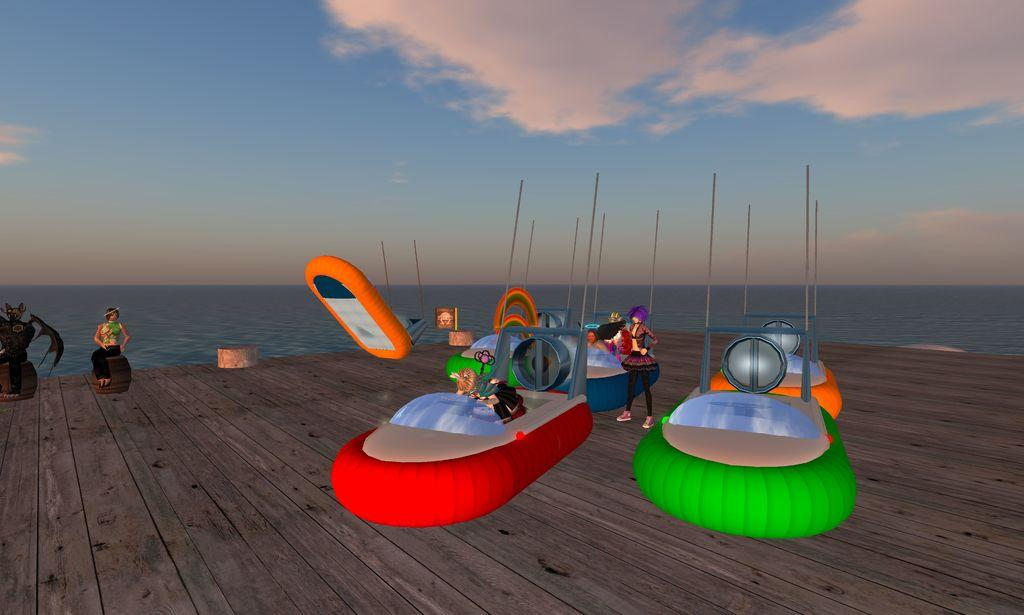What type of vehicles can be seen in the image? There are boats in the image. What structures are present in the image? There are poles in the image. Who or what is visible in the image? There are persons in the image. What type of surface is underfoot in the image? There is a wooden floor in the image. What natural element is visible in the image? Water is visible in the image. What is visible in the sky in the image? The sky is visible in the image, and clouds are present. How far away is the picture in the image? There is no picture present in the image; it features boats, poles, persons, a wooden floor, water, and the sky with clouds. What type of pot is being used to measure the distance between the boats in the image? There is no pot present in the image, and no measurements are being taken. 